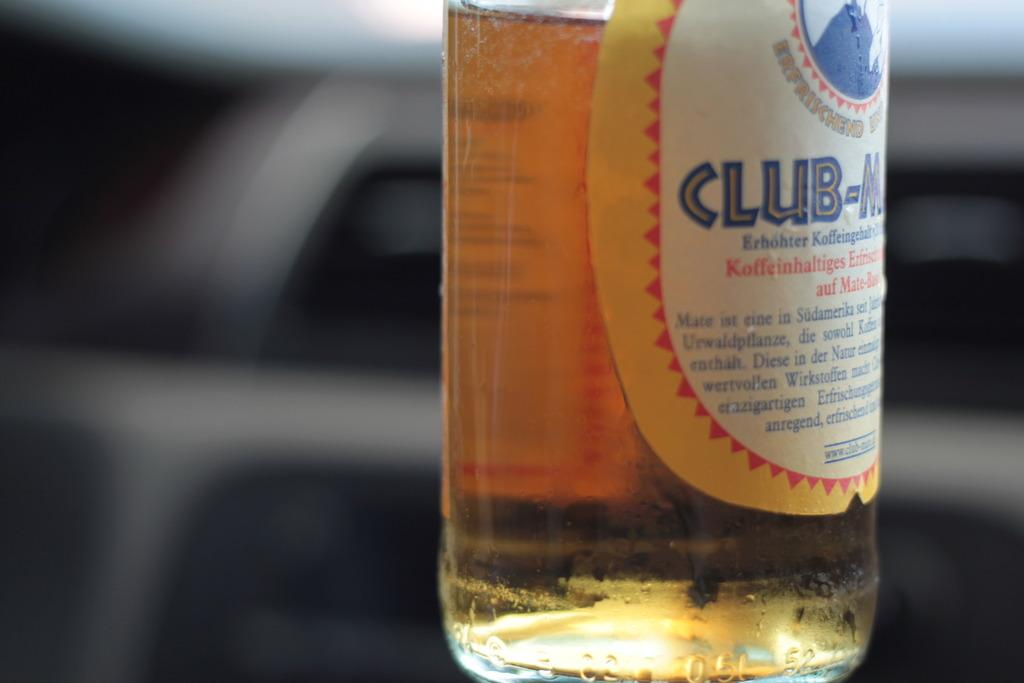<image>
Create a compact narrative representing the image presented. A bottle with the word club on it in blue is half full. 